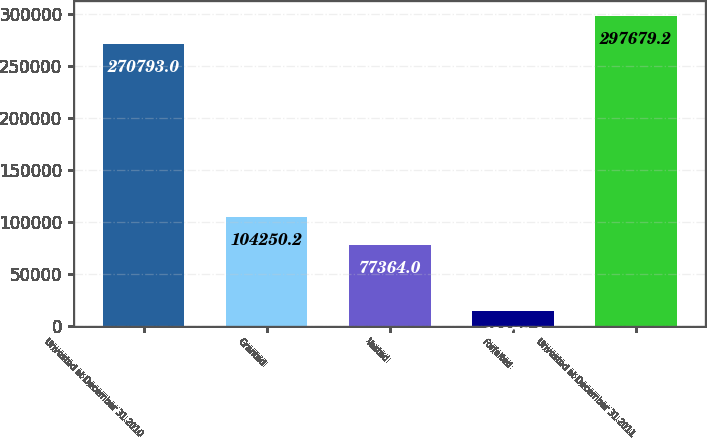<chart> <loc_0><loc_0><loc_500><loc_500><bar_chart><fcel>Unvested at December 31 2010<fcel>Granted<fcel>Vested<fcel>Forfeited<fcel>Unvested at December 31 2011<nl><fcel>270793<fcel>104250<fcel>77364<fcel>13975<fcel>297679<nl></chart> 